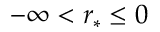<formula> <loc_0><loc_0><loc_500><loc_500>- \infty < r _ { * } \leq 0</formula> 